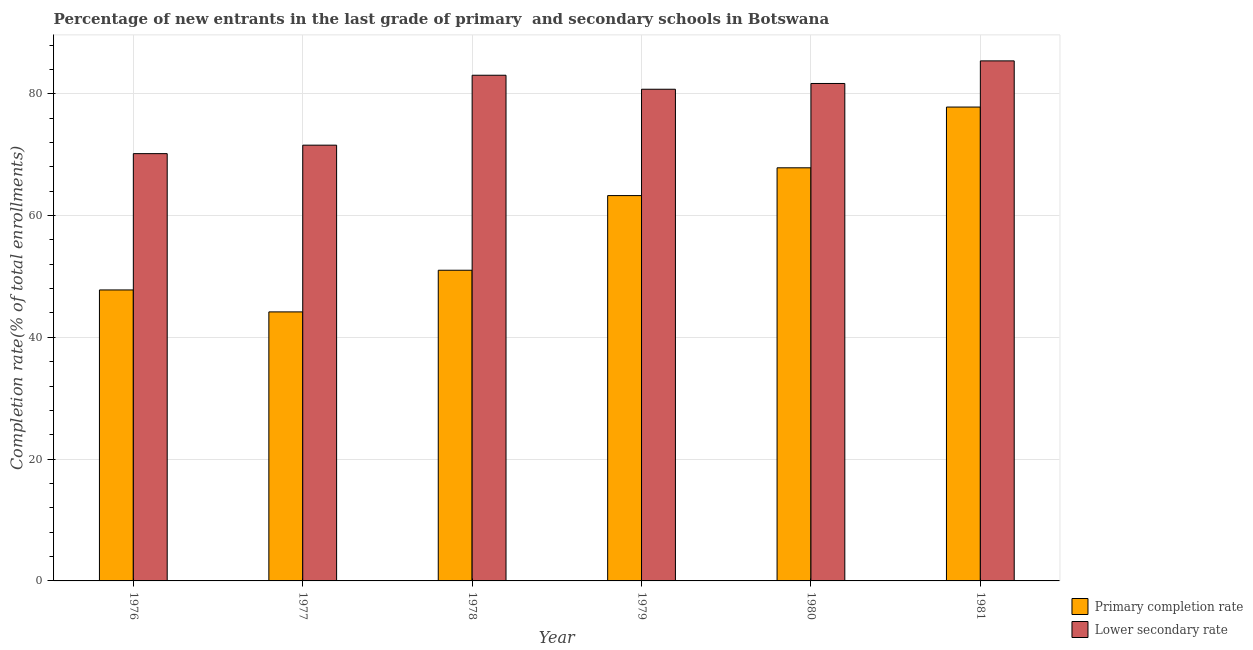How many groups of bars are there?
Provide a succinct answer. 6. Are the number of bars per tick equal to the number of legend labels?
Your answer should be very brief. Yes. Are the number of bars on each tick of the X-axis equal?
Make the answer very short. Yes. How many bars are there on the 2nd tick from the right?
Provide a short and direct response. 2. What is the label of the 1st group of bars from the left?
Keep it short and to the point. 1976. What is the completion rate in primary schools in 1978?
Your response must be concise. 51.01. Across all years, what is the maximum completion rate in secondary schools?
Provide a short and direct response. 85.39. Across all years, what is the minimum completion rate in secondary schools?
Provide a short and direct response. 70.16. In which year was the completion rate in secondary schools maximum?
Ensure brevity in your answer.  1981. In which year was the completion rate in secondary schools minimum?
Ensure brevity in your answer.  1976. What is the total completion rate in secondary schools in the graph?
Your answer should be very brief. 472.56. What is the difference between the completion rate in secondary schools in 1978 and that in 1981?
Your answer should be very brief. -2.36. What is the difference between the completion rate in primary schools in 1980 and the completion rate in secondary schools in 1981?
Your response must be concise. -9.98. What is the average completion rate in secondary schools per year?
Give a very brief answer. 78.76. In how many years, is the completion rate in secondary schools greater than 72 %?
Your answer should be very brief. 4. What is the ratio of the completion rate in primary schools in 1978 to that in 1981?
Ensure brevity in your answer.  0.66. What is the difference between the highest and the second highest completion rate in primary schools?
Provide a succinct answer. 9.98. What is the difference between the highest and the lowest completion rate in primary schools?
Provide a short and direct response. 33.64. In how many years, is the completion rate in secondary schools greater than the average completion rate in secondary schools taken over all years?
Provide a succinct answer. 4. Is the sum of the completion rate in primary schools in 1978 and 1980 greater than the maximum completion rate in secondary schools across all years?
Your answer should be very brief. Yes. What does the 2nd bar from the left in 1980 represents?
Your answer should be very brief. Lower secondary rate. What does the 1st bar from the right in 1976 represents?
Offer a very short reply. Lower secondary rate. How many bars are there?
Offer a very short reply. 12. Are all the bars in the graph horizontal?
Your response must be concise. No. Are the values on the major ticks of Y-axis written in scientific E-notation?
Your answer should be very brief. No. Does the graph contain grids?
Make the answer very short. Yes. Where does the legend appear in the graph?
Give a very brief answer. Bottom right. How many legend labels are there?
Offer a terse response. 2. How are the legend labels stacked?
Make the answer very short. Vertical. What is the title of the graph?
Keep it short and to the point. Percentage of new entrants in the last grade of primary  and secondary schools in Botswana. What is the label or title of the Y-axis?
Your answer should be compact. Completion rate(% of total enrollments). What is the Completion rate(% of total enrollments) of Primary completion rate in 1976?
Give a very brief answer. 47.78. What is the Completion rate(% of total enrollments) of Lower secondary rate in 1976?
Your answer should be compact. 70.16. What is the Completion rate(% of total enrollments) in Primary completion rate in 1977?
Your response must be concise. 44.17. What is the Completion rate(% of total enrollments) of Lower secondary rate in 1977?
Ensure brevity in your answer.  71.55. What is the Completion rate(% of total enrollments) of Primary completion rate in 1978?
Provide a short and direct response. 51.01. What is the Completion rate(% of total enrollments) in Lower secondary rate in 1978?
Your response must be concise. 83.03. What is the Completion rate(% of total enrollments) in Primary completion rate in 1979?
Offer a terse response. 63.27. What is the Completion rate(% of total enrollments) of Lower secondary rate in 1979?
Ensure brevity in your answer.  80.74. What is the Completion rate(% of total enrollments) in Primary completion rate in 1980?
Make the answer very short. 67.83. What is the Completion rate(% of total enrollments) of Lower secondary rate in 1980?
Keep it short and to the point. 81.68. What is the Completion rate(% of total enrollments) of Primary completion rate in 1981?
Ensure brevity in your answer.  77.81. What is the Completion rate(% of total enrollments) of Lower secondary rate in 1981?
Offer a very short reply. 85.39. Across all years, what is the maximum Completion rate(% of total enrollments) of Primary completion rate?
Provide a short and direct response. 77.81. Across all years, what is the maximum Completion rate(% of total enrollments) of Lower secondary rate?
Provide a short and direct response. 85.39. Across all years, what is the minimum Completion rate(% of total enrollments) of Primary completion rate?
Offer a terse response. 44.17. Across all years, what is the minimum Completion rate(% of total enrollments) of Lower secondary rate?
Offer a terse response. 70.16. What is the total Completion rate(% of total enrollments) of Primary completion rate in the graph?
Keep it short and to the point. 351.89. What is the total Completion rate(% of total enrollments) in Lower secondary rate in the graph?
Your answer should be very brief. 472.56. What is the difference between the Completion rate(% of total enrollments) in Primary completion rate in 1976 and that in 1977?
Provide a succinct answer. 3.6. What is the difference between the Completion rate(% of total enrollments) of Lower secondary rate in 1976 and that in 1977?
Offer a very short reply. -1.39. What is the difference between the Completion rate(% of total enrollments) in Primary completion rate in 1976 and that in 1978?
Your response must be concise. -3.24. What is the difference between the Completion rate(% of total enrollments) in Lower secondary rate in 1976 and that in 1978?
Ensure brevity in your answer.  -12.87. What is the difference between the Completion rate(% of total enrollments) of Primary completion rate in 1976 and that in 1979?
Keep it short and to the point. -15.49. What is the difference between the Completion rate(% of total enrollments) in Lower secondary rate in 1976 and that in 1979?
Provide a succinct answer. -10.57. What is the difference between the Completion rate(% of total enrollments) in Primary completion rate in 1976 and that in 1980?
Your answer should be very brief. -20.06. What is the difference between the Completion rate(% of total enrollments) in Lower secondary rate in 1976 and that in 1980?
Offer a very short reply. -11.52. What is the difference between the Completion rate(% of total enrollments) in Primary completion rate in 1976 and that in 1981?
Make the answer very short. -30.03. What is the difference between the Completion rate(% of total enrollments) of Lower secondary rate in 1976 and that in 1981?
Make the answer very short. -15.23. What is the difference between the Completion rate(% of total enrollments) in Primary completion rate in 1977 and that in 1978?
Ensure brevity in your answer.  -6.84. What is the difference between the Completion rate(% of total enrollments) of Lower secondary rate in 1977 and that in 1978?
Your response must be concise. -11.48. What is the difference between the Completion rate(% of total enrollments) of Primary completion rate in 1977 and that in 1979?
Your answer should be compact. -19.1. What is the difference between the Completion rate(% of total enrollments) of Lower secondary rate in 1977 and that in 1979?
Offer a very short reply. -9.18. What is the difference between the Completion rate(% of total enrollments) of Primary completion rate in 1977 and that in 1980?
Your answer should be very brief. -23.66. What is the difference between the Completion rate(% of total enrollments) of Lower secondary rate in 1977 and that in 1980?
Give a very brief answer. -10.13. What is the difference between the Completion rate(% of total enrollments) in Primary completion rate in 1977 and that in 1981?
Your answer should be compact. -33.64. What is the difference between the Completion rate(% of total enrollments) of Lower secondary rate in 1977 and that in 1981?
Your answer should be compact. -13.84. What is the difference between the Completion rate(% of total enrollments) in Primary completion rate in 1978 and that in 1979?
Your answer should be compact. -12.26. What is the difference between the Completion rate(% of total enrollments) in Lower secondary rate in 1978 and that in 1979?
Your answer should be very brief. 2.3. What is the difference between the Completion rate(% of total enrollments) in Primary completion rate in 1978 and that in 1980?
Provide a short and direct response. -16.82. What is the difference between the Completion rate(% of total enrollments) of Lower secondary rate in 1978 and that in 1980?
Provide a succinct answer. 1.35. What is the difference between the Completion rate(% of total enrollments) in Primary completion rate in 1978 and that in 1981?
Provide a short and direct response. -26.79. What is the difference between the Completion rate(% of total enrollments) of Lower secondary rate in 1978 and that in 1981?
Ensure brevity in your answer.  -2.36. What is the difference between the Completion rate(% of total enrollments) of Primary completion rate in 1979 and that in 1980?
Give a very brief answer. -4.56. What is the difference between the Completion rate(% of total enrollments) of Lower secondary rate in 1979 and that in 1980?
Your answer should be very brief. -0.95. What is the difference between the Completion rate(% of total enrollments) in Primary completion rate in 1979 and that in 1981?
Provide a short and direct response. -14.54. What is the difference between the Completion rate(% of total enrollments) in Lower secondary rate in 1979 and that in 1981?
Provide a succinct answer. -4.66. What is the difference between the Completion rate(% of total enrollments) of Primary completion rate in 1980 and that in 1981?
Your answer should be compact. -9.98. What is the difference between the Completion rate(% of total enrollments) in Lower secondary rate in 1980 and that in 1981?
Make the answer very short. -3.71. What is the difference between the Completion rate(% of total enrollments) in Primary completion rate in 1976 and the Completion rate(% of total enrollments) in Lower secondary rate in 1977?
Your answer should be very brief. -23.78. What is the difference between the Completion rate(% of total enrollments) in Primary completion rate in 1976 and the Completion rate(% of total enrollments) in Lower secondary rate in 1978?
Provide a succinct answer. -35.26. What is the difference between the Completion rate(% of total enrollments) of Primary completion rate in 1976 and the Completion rate(% of total enrollments) of Lower secondary rate in 1979?
Give a very brief answer. -32.96. What is the difference between the Completion rate(% of total enrollments) in Primary completion rate in 1976 and the Completion rate(% of total enrollments) in Lower secondary rate in 1980?
Your response must be concise. -33.9. What is the difference between the Completion rate(% of total enrollments) of Primary completion rate in 1976 and the Completion rate(% of total enrollments) of Lower secondary rate in 1981?
Your answer should be compact. -37.62. What is the difference between the Completion rate(% of total enrollments) in Primary completion rate in 1977 and the Completion rate(% of total enrollments) in Lower secondary rate in 1978?
Offer a terse response. -38.86. What is the difference between the Completion rate(% of total enrollments) of Primary completion rate in 1977 and the Completion rate(% of total enrollments) of Lower secondary rate in 1979?
Your response must be concise. -36.56. What is the difference between the Completion rate(% of total enrollments) of Primary completion rate in 1977 and the Completion rate(% of total enrollments) of Lower secondary rate in 1980?
Give a very brief answer. -37.51. What is the difference between the Completion rate(% of total enrollments) of Primary completion rate in 1977 and the Completion rate(% of total enrollments) of Lower secondary rate in 1981?
Ensure brevity in your answer.  -41.22. What is the difference between the Completion rate(% of total enrollments) in Primary completion rate in 1978 and the Completion rate(% of total enrollments) in Lower secondary rate in 1979?
Offer a terse response. -29.72. What is the difference between the Completion rate(% of total enrollments) of Primary completion rate in 1978 and the Completion rate(% of total enrollments) of Lower secondary rate in 1980?
Your answer should be compact. -30.67. What is the difference between the Completion rate(% of total enrollments) in Primary completion rate in 1978 and the Completion rate(% of total enrollments) in Lower secondary rate in 1981?
Your answer should be very brief. -34.38. What is the difference between the Completion rate(% of total enrollments) in Primary completion rate in 1979 and the Completion rate(% of total enrollments) in Lower secondary rate in 1980?
Your response must be concise. -18.41. What is the difference between the Completion rate(% of total enrollments) in Primary completion rate in 1979 and the Completion rate(% of total enrollments) in Lower secondary rate in 1981?
Provide a succinct answer. -22.12. What is the difference between the Completion rate(% of total enrollments) of Primary completion rate in 1980 and the Completion rate(% of total enrollments) of Lower secondary rate in 1981?
Your response must be concise. -17.56. What is the average Completion rate(% of total enrollments) in Primary completion rate per year?
Provide a succinct answer. 58.65. What is the average Completion rate(% of total enrollments) of Lower secondary rate per year?
Offer a terse response. 78.76. In the year 1976, what is the difference between the Completion rate(% of total enrollments) in Primary completion rate and Completion rate(% of total enrollments) in Lower secondary rate?
Your response must be concise. -22.38. In the year 1977, what is the difference between the Completion rate(% of total enrollments) in Primary completion rate and Completion rate(% of total enrollments) in Lower secondary rate?
Your answer should be compact. -27.38. In the year 1978, what is the difference between the Completion rate(% of total enrollments) in Primary completion rate and Completion rate(% of total enrollments) in Lower secondary rate?
Your response must be concise. -32.02. In the year 1979, what is the difference between the Completion rate(% of total enrollments) of Primary completion rate and Completion rate(% of total enrollments) of Lower secondary rate?
Make the answer very short. -17.46. In the year 1980, what is the difference between the Completion rate(% of total enrollments) of Primary completion rate and Completion rate(% of total enrollments) of Lower secondary rate?
Your answer should be compact. -13.85. In the year 1981, what is the difference between the Completion rate(% of total enrollments) of Primary completion rate and Completion rate(% of total enrollments) of Lower secondary rate?
Offer a terse response. -7.58. What is the ratio of the Completion rate(% of total enrollments) in Primary completion rate in 1976 to that in 1977?
Offer a very short reply. 1.08. What is the ratio of the Completion rate(% of total enrollments) in Lower secondary rate in 1976 to that in 1977?
Your response must be concise. 0.98. What is the ratio of the Completion rate(% of total enrollments) in Primary completion rate in 1976 to that in 1978?
Keep it short and to the point. 0.94. What is the ratio of the Completion rate(% of total enrollments) of Lower secondary rate in 1976 to that in 1978?
Keep it short and to the point. 0.84. What is the ratio of the Completion rate(% of total enrollments) of Primary completion rate in 1976 to that in 1979?
Your answer should be compact. 0.76. What is the ratio of the Completion rate(% of total enrollments) of Lower secondary rate in 1976 to that in 1979?
Provide a short and direct response. 0.87. What is the ratio of the Completion rate(% of total enrollments) in Primary completion rate in 1976 to that in 1980?
Provide a succinct answer. 0.7. What is the ratio of the Completion rate(% of total enrollments) in Lower secondary rate in 1976 to that in 1980?
Make the answer very short. 0.86. What is the ratio of the Completion rate(% of total enrollments) of Primary completion rate in 1976 to that in 1981?
Ensure brevity in your answer.  0.61. What is the ratio of the Completion rate(% of total enrollments) of Lower secondary rate in 1976 to that in 1981?
Your response must be concise. 0.82. What is the ratio of the Completion rate(% of total enrollments) in Primary completion rate in 1977 to that in 1978?
Make the answer very short. 0.87. What is the ratio of the Completion rate(% of total enrollments) of Lower secondary rate in 1977 to that in 1978?
Make the answer very short. 0.86. What is the ratio of the Completion rate(% of total enrollments) in Primary completion rate in 1977 to that in 1979?
Provide a short and direct response. 0.7. What is the ratio of the Completion rate(% of total enrollments) of Lower secondary rate in 1977 to that in 1979?
Provide a succinct answer. 0.89. What is the ratio of the Completion rate(% of total enrollments) in Primary completion rate in 1977 to that in 1980?
Provide a succinct answer. 0.65. What is the ratio of the Completion rate(% of total enrollments) of Lower secondary rate in 1977 to that in 1980?
Make the answer very short. 0.88. What is the ratio of the Completion rate(% of total enrollments) of Primary completion rate in 1977 to that in 1981?
Your answer should be compact. 0.57. What is the ratio of the Completion rate(% of total enrollments) of Lower secondary rate in 1977 to that in 1981?
Offer a very short reply. 0.84. What is the ratio of the Completion rate(% of total enrollments) in Primary completion rate in 1978 to that in 1979?
Offer a terse response. 0.81. What is the ratio of the Completion rate(% of total enrollments) of Lower secondary rate in 1978 to that in 1979?
Provide a short and direct response. 1.03. What is the ratio of the Completion rate(% of total enrollments) of Primary completion rate in 1978 to that in 1980?
Give a very brief answer. 0.75. What is the ratio of the Completion rate(% of total enrollments) in Lower secondary rate in 1978 to that in 1980?
Your answer should be compact. 1.02. What is the ratio of the Completion rate(% of total enrollments) of Primary completion rate in 1978 to that in 1981?
Offer a very short reply. 0.66. What is the ratio of the Completion rate(% of total enrollments) in Lower secondary rate in 1978 to that in 1981?
Offer a very short reply. 0.97. What is the ratio of the Completion rate(% of total enrollments) in Primary completion rate in 1979 to that in 1980?
Your answer should be very brief. 0.93. What is the ratio of the Completion rate(% of total enrollments) of Lower secondary rate in 1979 to that in 1980?
Your answer should be compact. 0.99. What is the ratio of the Completion rate(% of total enrollments) in Primary completion rate in 1979 to that in 1981?
Give a very brief answer. 0.81. What is the ratio of the Completion rate(% of total enrollments) of Lower secondary rate in 1979 to that in 1981?
Give a very brief answer. 0.95. What is the ratio of the Completion rate(% of total enrollments) of Primary completion rate in 1980 to that in 1981?
Give a very brief answer. 0.87. What is the ratio of the Completion rate(% of total enrollments) of Lower secondary rate in 1980 to that in 1981?
Your answer should be compact. 0.96. What is the difference between the highest and the second highest Completion rate(% of total enrollments) of Primary completion rate?
Keep it short and to the point. 9.98. What is the difference between the highest and the second highest Completion rate(% of total enrollments) in Lower secondary rate?
Offer a terse response. 2.36. What is the difference between the highest and the lowest Completion rate(% of total enrollments) of Primary completion rate?
Your response must be concise. 33.64. What is the difference between the highest and the lowest Completion rate(% of total enrollments) in Lower secondary rate?
Your answer should be compact. 15.23. 